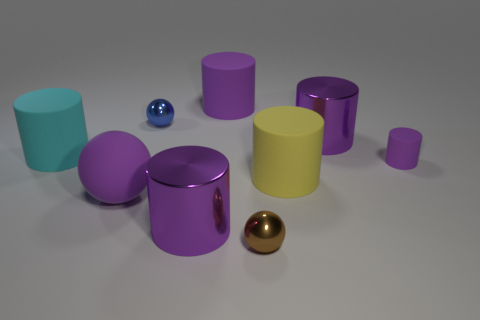How many red things are either rubber cylinders or matte balls?
Your response must be concise. 0. Is there a metal sphere that has the same color as the matte sphere?
Your answer should be compact. No. Are there any tiny brown things made of the same material as the yellow cylinder?
Your answer should be compact. No. What is the shape of the thing that is both left of the tiny blue thing and behind the yellow rubber object?
Offer a terse response. Cylinder. How many small objects are yellow matte objects or matte things?
Provide a short and direct response. 1. What is the brown sphere made of?
Your answer should be very brief. Metal. What number of other objects are the same shape as the cyan thing?
Your answer should be very brief. 5. The blue thing is what size?
Your response must be concise. Small. There is a sphere that is in front of the small purple cylinder and behind the brown object; what is its size?
Make the answer very short. Large. What is the shape of the large purple shiny thing that is behind the cyan cylinder?
Offer a terse response. Cylinder. 